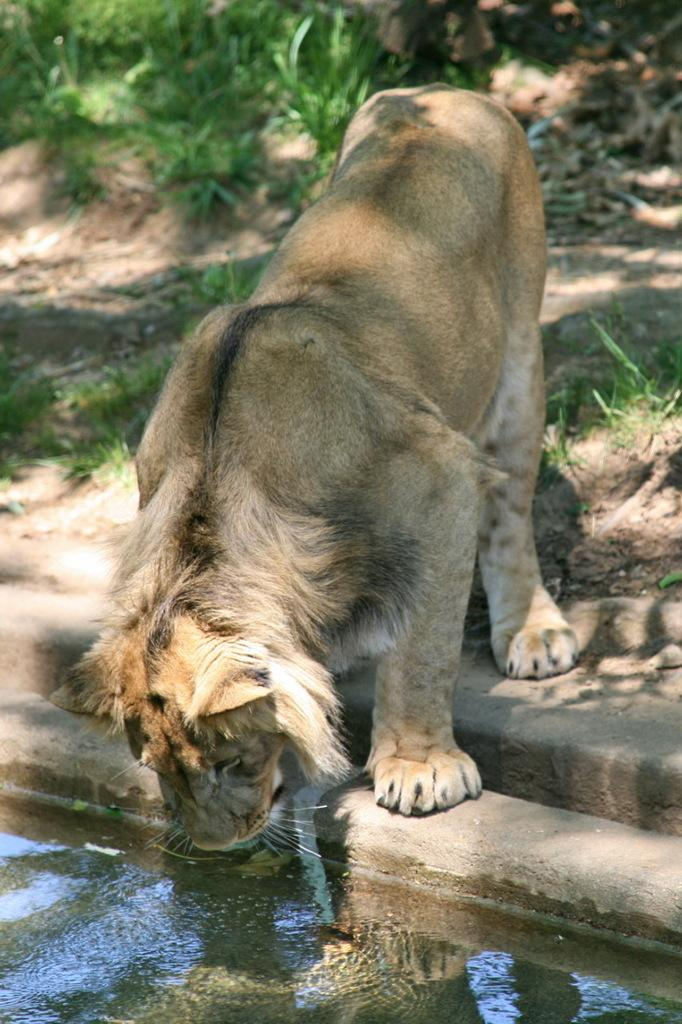What animal is present in the image? There is a lion in the image. What is located at the bottom of the image? There is water at the bottom of the image. What type of vegetation can be seen in the background of the image? There are plants on the ground in the background of the image. Where is the wrench being used in the image? There is no wrench present in the image. What type of tea can be brewed in the kettle in the image? There is no kettle present in the image. 